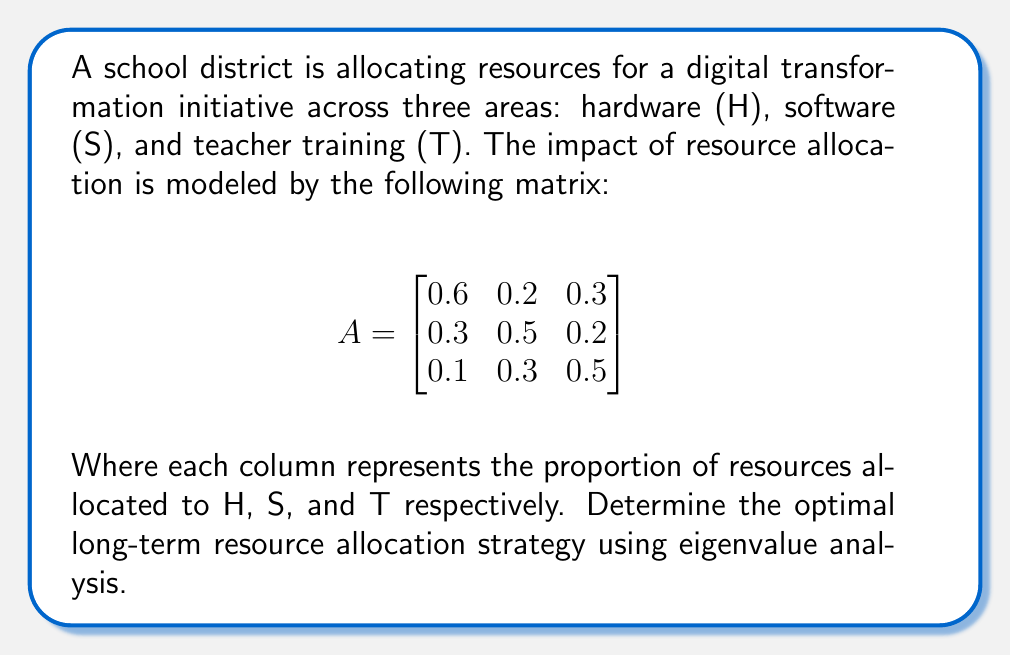What is the answer to this math problem? To find the optimal long-term resource allocation strategy, we need to find the eigenvector corresponding to the largest eigenvalue of matrix A. This eigenvector will represent the stable state of resource allocation.

Step 1: Find the characteristic equation of A
$$det(A - \lambda I) = 0$$
$$\begin{vmatrix}
0.6-\lambda & 0.2 & 0.3 \\
0.3 & 0.5-\lambda & 0.2 \\
0.1 & 0.3 & 0.5-\lambda
\end{vmatrix} = 0$$

Step 2: Solve the characteristic equation
$$(0.6-\lambda)(0.5-\lambda)(0.5-\lambda) - 0.2(0.3)(0.5-\lambda) - 0.3(0.3)(0.3) = 0$$
$$-\lambda^3 + 1.6\lambda^2 - 0.71\lambda + 0.087 = 0$$

Step 3: Find the eigenvalues
Using a numerical method or calculator, we find the eigenvalues:
$\lambda_1 \approx 1.0395$ (largest)
$\lambda_2 \approx 0.3302$
$\lambda_3 \approx 0.2303$

Step 4: Find the eigenvector corresponding to $\lambda_1$
$$(A - \lambda_1 I)v = 0$$
Solving this system of equations, we get the eigenvector:
$$v \approx \begin{bmatrix}
0.6325 \\
0.5476 \\
0.5476
\end{bmatrix}$$

Step 5: Normalize the eigenvector
Divide each component by the sum of all components:
$$v_{normalized} \approx \begin{bmatrix}
0.3661 \\
0.3169 \\
0.3169
\end{bmatrix}$$

This normalized eigenvector represents the optimal long-term resource allocation strategy.
Answer: H: 36.61%, S: 31.69%, T: 31.69% 